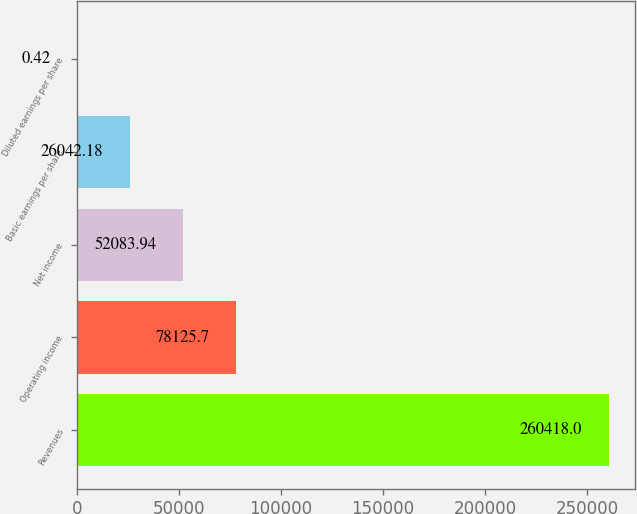Convert chart to OTSL. <chart><loc_0><loc_0><loc_500><loc_500><bar_chart><fcel>Revenues<fcel>Operating income<fcel>Net income<fcel>Basic earnings per share<fcel>Diluted earnings per share<nl><fcel>260418<fcel>78125.7<fcel>52083.9<fcel>26042.2<fcel>0.42<nl></chart> 